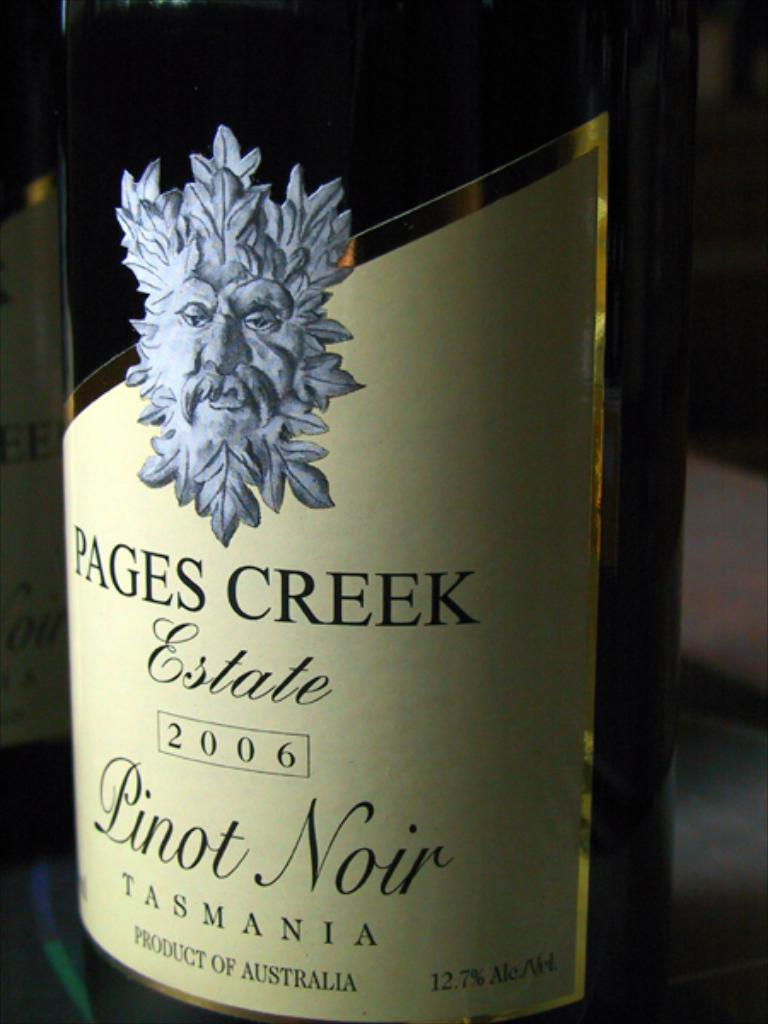<image>
Write a terse but informative summary of the picture. Bottle of Pages Creek Estate wine with a drawing of a face on it. 